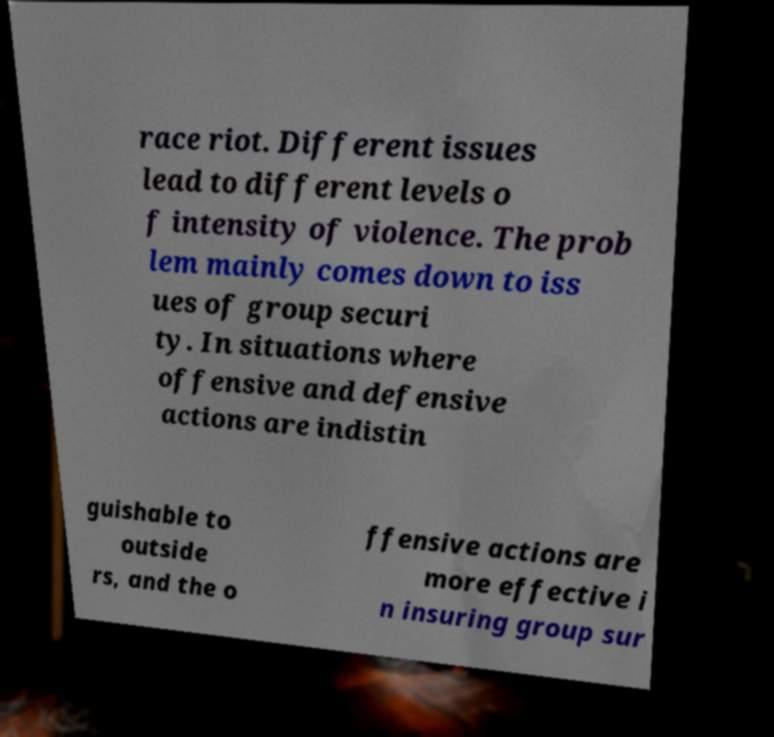Could you extract and type out the text from this image? race riot. Different issues lead to different levels o f intensity of violence. The prob lem mainly comes down to iss ues of group securi ty. In situations where offensive and defensive actions are indistin guishable to outside rs, and the o ffensive actions are more effective i n insuring group sur 